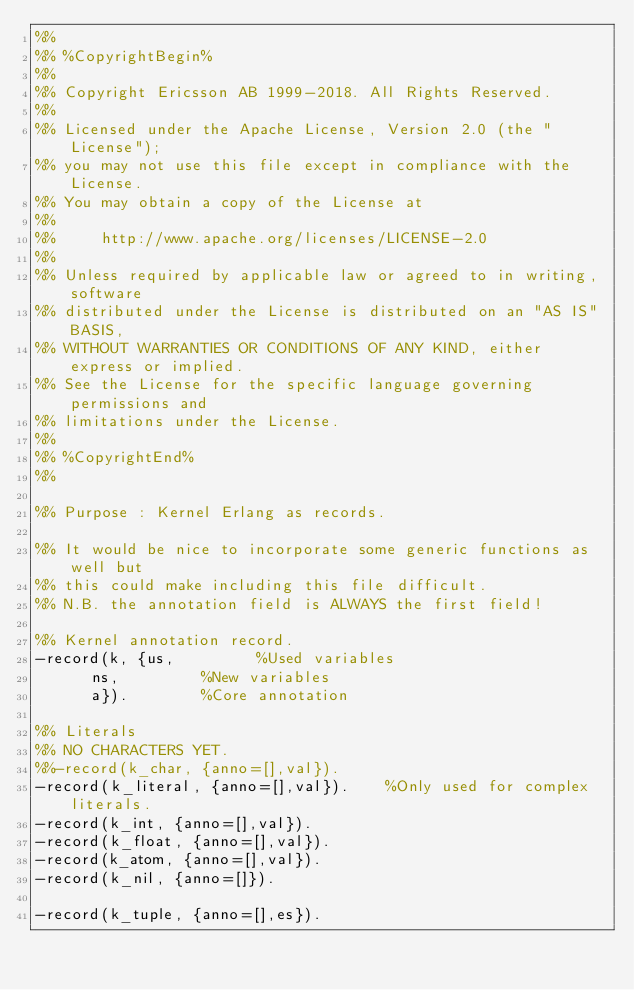Convert code to text. <code><loc_0><loc_0><loc_500><loc_500><_Erlang_>%%
%% %CopyrightBegin%
%% 
%% Copyright Ericsson AB 1999-2018. All Rights Reserved.
%% 
%% Licensed under the Apache License, Version 2.0 (the "License");
%% you may not use this file except in compliance with the License.
%% You may obtain a copy of the License at
%%
%%     http://www.apache.org/licenses/LICENSE-2.0
%%
%% Unless required by applicable law or agreed to in writing, software
%% distributed under the License is distributed on an "AS IS" BASIS,
%% WITHOUT WARRANTIES OR CONDITIONS OF ANY KIND, either express or implied.
%% See the License for the specific language governing permissions and
%% limitations under the License.
%% 
%% %CopyrightEnd%
%%

%% Purpose : Kernel Erlang as records.

%% It would be nice to incorporate some generic functions as well but
%% this could make including this file difficult.
%% N.B. the annotation field is ALWAYS the first field!

%% Kernel annotation record.
-record(k, {us,					%Used variables
	    ns,					%New variables
	    a}).				%Core annotation

%% Literals
%% NO CHARACTERS YET.
%%-record(k_char, {anno=[],val}).
-record(k_literal, {anno=[],val}).		%Only used for complex literals.
-record(k_int, {anno=[],val}).
-record(k_float, {anno=[],val}).
-record(k_atom, {anno=[],val}).
-record(k_nil, {anno=[]}).

-record(k_tuple, {anno=[],es}).</code> 